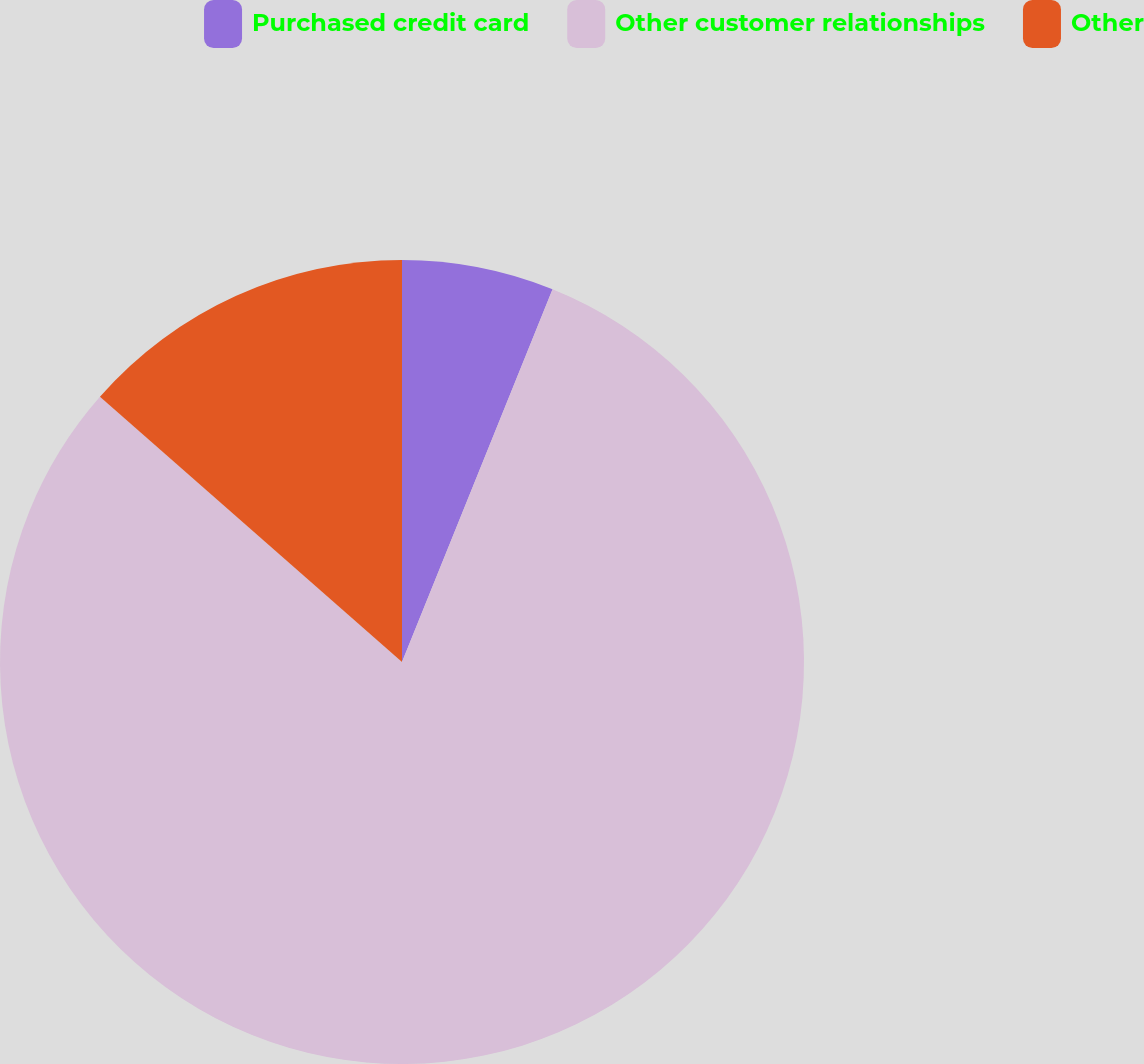Convert chart to OTSL. <chart><loc_0><loc_0><loc_500><loc_500><pie_chart><fcel>Purchased credit card<fcel>Other customer relationships<fcel>Other<nl><fcel>6.11%<fcel>80.36%<fcel>13.53%<nl></chart> 